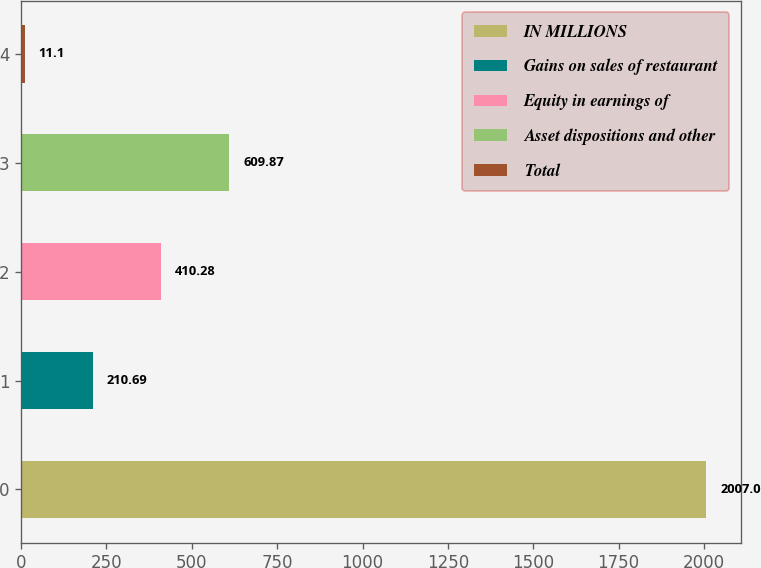Convert chart. <chart><loc_0><loc_0><loc_500><loc_500><bar_chart><fcel>IN MILLIONS<fcel>Gains on sales of restaurant<fcel>Equity in earnings of<fcel>Asset dispositions and other<fcel>Total<nl><fcel>2007<fcel>210.69<fcel>410.28<fcel>609.87<fcel>11.1<nl></chart> 